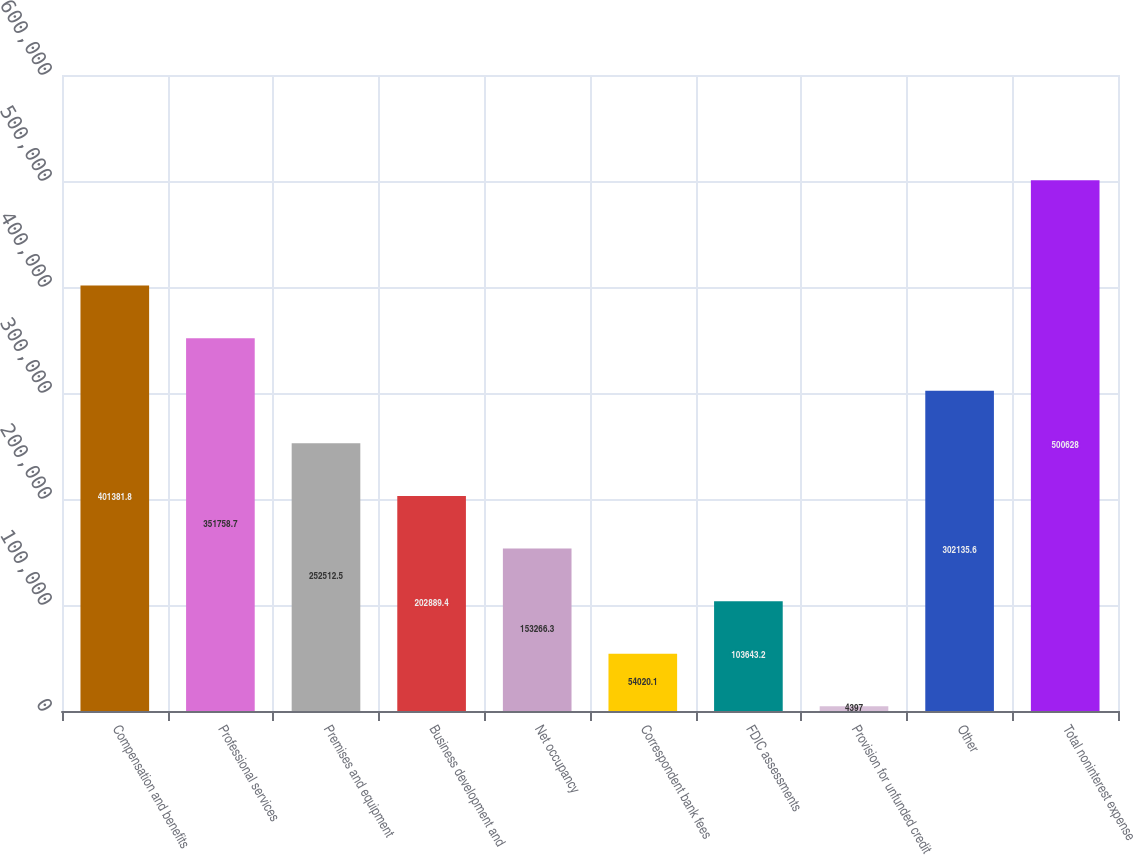Convert chart. <chart><loc_0><loc_0><loc_500><loc_500><bar_chart><fcel>Compensation and benefits<fcel>Professional services<fcel>Premises and equipment<fcel>Business development and<fcel>Net occupancy<fcel>Correspondent bank fees<fcel>FDIC assessments<fcel>Provision for unfunded credit<fcel>Other<fcel>Total noninterest expense<nl><fcel>401382<fcel>351759<fcel>252512<fcel>202889<fcel>153266<fcel>54020.1<fcel>103643<fcel>4397<fcel>302136<fcel>500628<nl></chart> 